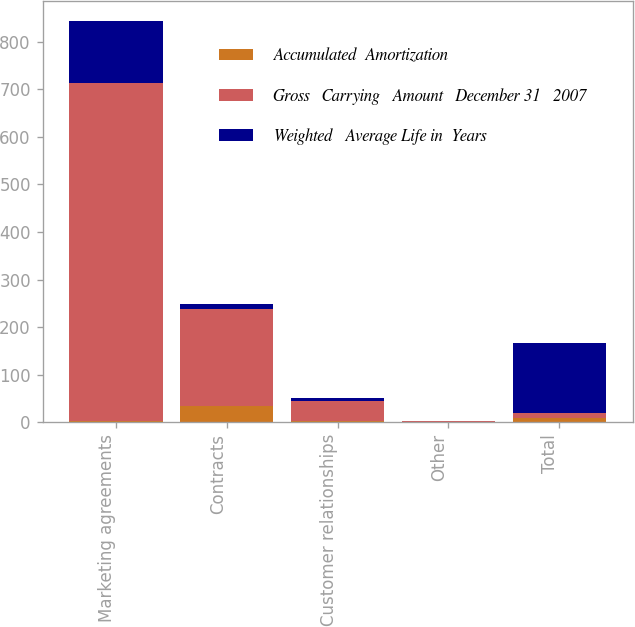Convert chart. <chart><loc_0><loc_0><loc_500><loc_500><stacked_bar_chart><ecel><fcel>Marketing agreements<fcel>Contracts<fcel>Customer relationships<fcel>Other<fcel>Total<nl><fcel>Accumulated  Amortization<fcel>4<fcel>34<fcel>4<fcel>1<fcel>10<nl><fcel>Gross   Carrying   Amount   December 31   2007<fcel>710<fcel>205<fcel>40<fcel>1<fcel>10<nl><fcel>Weighted   Average Life in  Years<fcel>129<fcel>10<fcel>7<fcel>1<fcel>147<nl></chart> 